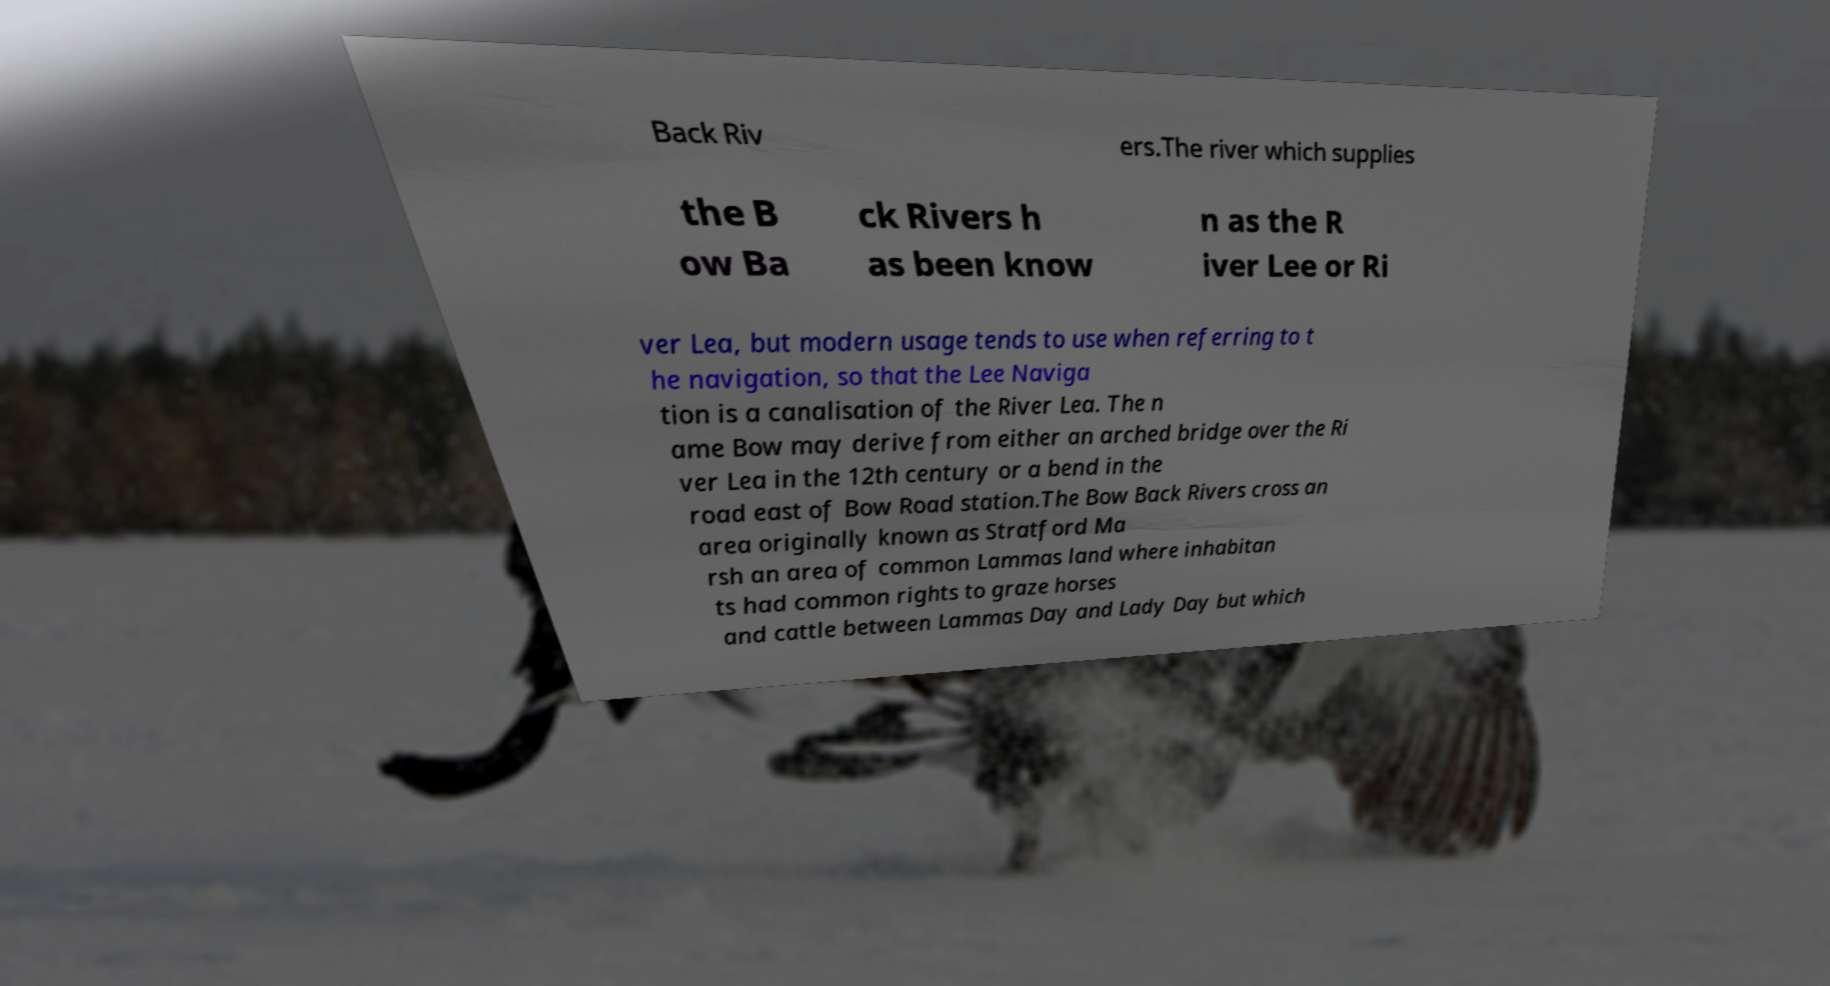I need the written content from this picture converted into text. Can you do that? Back Riv ers.The river which supplies the B ow Ba ck Rivers h as been know n as the R iver Lee or Ri ver Lea, but modern usage tends to use when referring to t he navigation, so that the Lee Naviga tion is a canalisation of the River Lea. The n ame Bow may derive from either an arched bridge over the Ri ver Lea in the 12th century or a bend in the road east of Bow Road station.The Bow Back Rivers cross an area originally known as Stratford Ma rsh an area of common Lammas land where inhabitan ts had common rights to graze horses and cattle between Lammas Day and Lady Day but which 